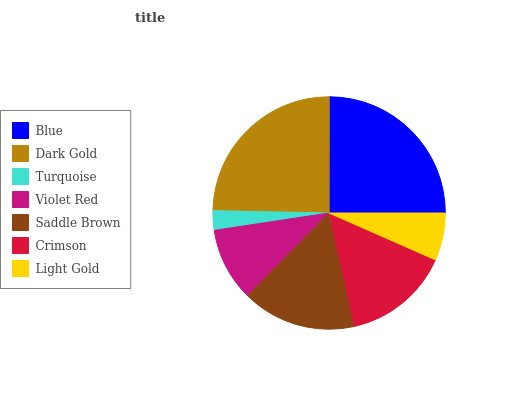Is Turquoise the minimum?
Answer yes or no. Yes. Is Blue the maximum?
Answer yes or no. Yes. Is Dark Gold the minimum?
Answer yes or no. No. Is Dark Gold the maximum?
Answer yes or no. No. Is Blue greater than Dark Gold?
Answer yes or no. Yes. Is Dark Gold less than Blue?
Answer yes or no. Yes. Is Dark Gold greater than Blue?
Answer yes or no. No. Is Blue less than Dark Gold?
Answer yes or no. No. Is Crimson the high median?
Answer yes or no. Yes. Is Crimson the low median?
Answer yes or no. Yes. Is Dark Gold the high median?
Answer yes or no. No. Is Light Gold the low median?
Answer yes or no. No. 